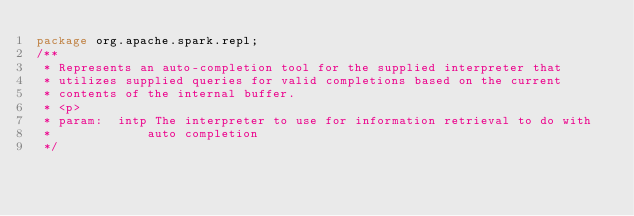<code> <loc_0><loc_0><loc_500><loc_500><_Java_>package org.apache.spark.repl;
/**
 * Represents an auto-completion tool for the supplied interpreter that
 * utilizes supplied queries for valid completions based on the current
 * contents of the internal buffer.
 * <p>
 * param:  intp The interpreter to use for information retrieval to do with
 *             auto completion
 */</code> 